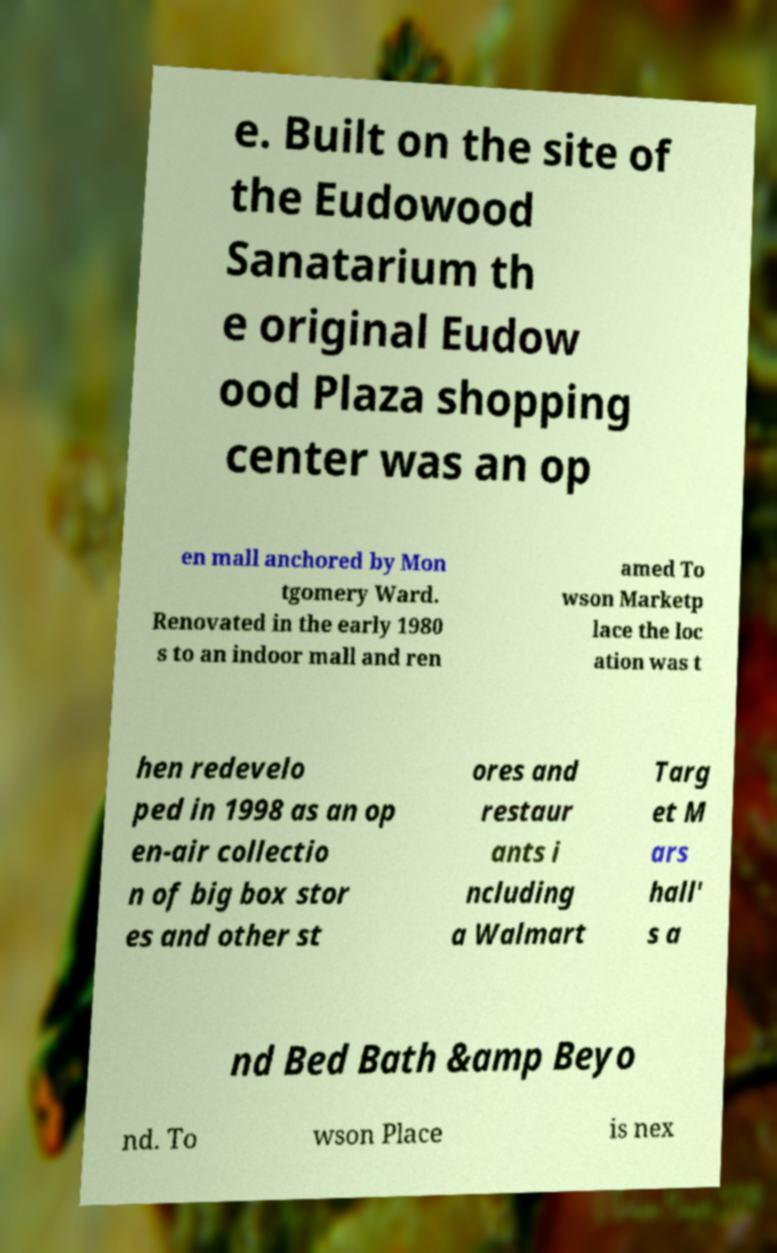I need the written content from this picture converted into text. Can you do that? e. Built on the site of the Eudowood Sanatarium th e original Eudow ood Plaza shopping center was an op en mall anchored by Mon tgomery Ward. Renovated in the early 1980 s to an indoor mall and ren amed To wson Marketp lace the loc ation was t hen redevelo ped in 1998 as an op en-air collectio n of big box stor es and other st ores and restaur ants i ncluding a Walmart Targ et M ars hall' s a nd Bed Bath &amp Beyo nd. To wson Place is nex 